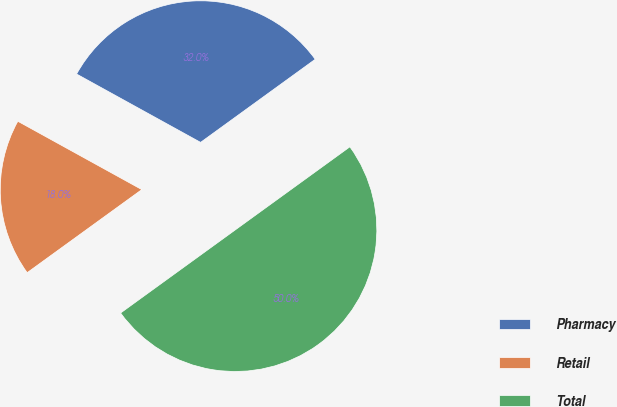Convert chart to OTSL. <chart><loc_0><loc_0><loc_500><loc_500><pie_chart><fcel>Pharmacy<fcel>Retail<fcel>Total<nl><fcel>32.0%<fcel>18.0%<fcel>50.0%<nl></chart> 